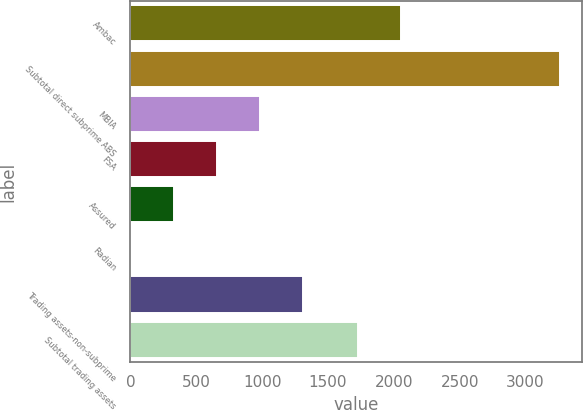Convert chart. <chart><loc_0><loc_0><loc_500><loc_500><bar_chart><fcel>Ambac<fcel>Subtotal direct subprime ABS<fcel>MBIA<fcel>FSA<fcel>Assured<fcel>Radian<fcel>Trading assets-non-subprime<fcel>Subtotal trading assets<nl><fcel>2053.7<fcel>3262<fcel>982.1<fcel>656.4<fcel>330.7<fcel>5<fcel>1307.8<fcel>1728<nl></chart> 